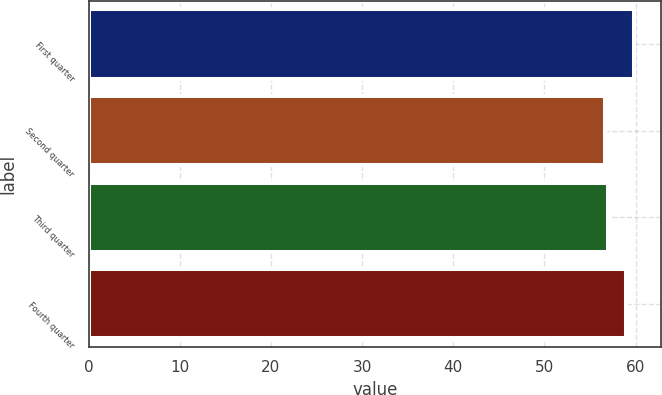Convert chart. <chart><loc_0><loc_0><loc_500><loc_500><bar_chart><fcel>First quarter<fcel>Second quarter<fcel>Third quarter<fcel>Fourth quarter<nl><fcel>59.81<fcel>56.68<fcel>56.99<fcel>58.97<nl></chart> 